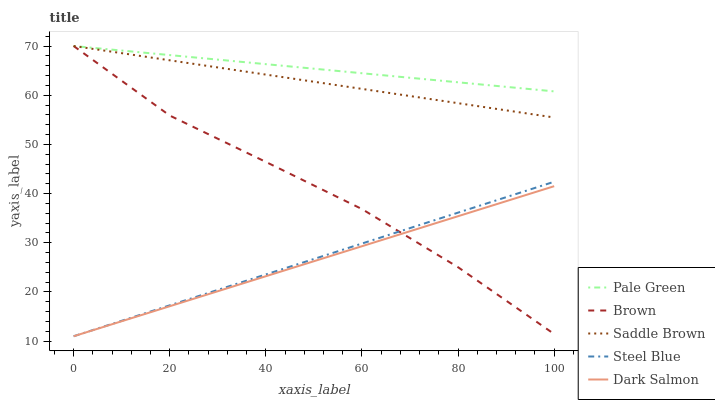Does Dark Salmon have the minimum area under the curve?
Answer yes or no. Yes. Does Pale Green have the maximum area under the curve?
Answer yes or no. Yes. Does Pale Green have the minimum area under the curve?
Answer yes or no. No. Does Dark Salmon have the maximum area under the curve?
Answer yes or no. No. Is Dark Salmon the smoothest?
Answer yes or no. Yes. Is Brown the roughest?
Answer yes or no. Yes. Is Pale Green the smoothest?
Answer yes or no. No. Is Pale Green the roughest?
Answer yes or no. No. Does Dark Salmon have the lowest value?
Answer yes or no. Yes. Does Pale Green have the lowest value?
Answer yes or no. No. Does Saddle Brown have the highest value?
Answer yes or no. Yes. Does Dark Salmon have the highest value?
Answer yes or no. No. Is Steel Blue less than Pale Green?
Answer yes or no. Yes. Is Saddle Brown greater than Dark Salmon?
Answer yes or no. Yes. Does Pale Green intersect Brown?
Answer yes or no. Yes. Is Pale Green less than Brown?
Answer yes or no. No. Is Pale Green greater than Brown?
Answer yes or no. No. Does Steel Blue intersect Pale Green?
Answer yes or no. No. 